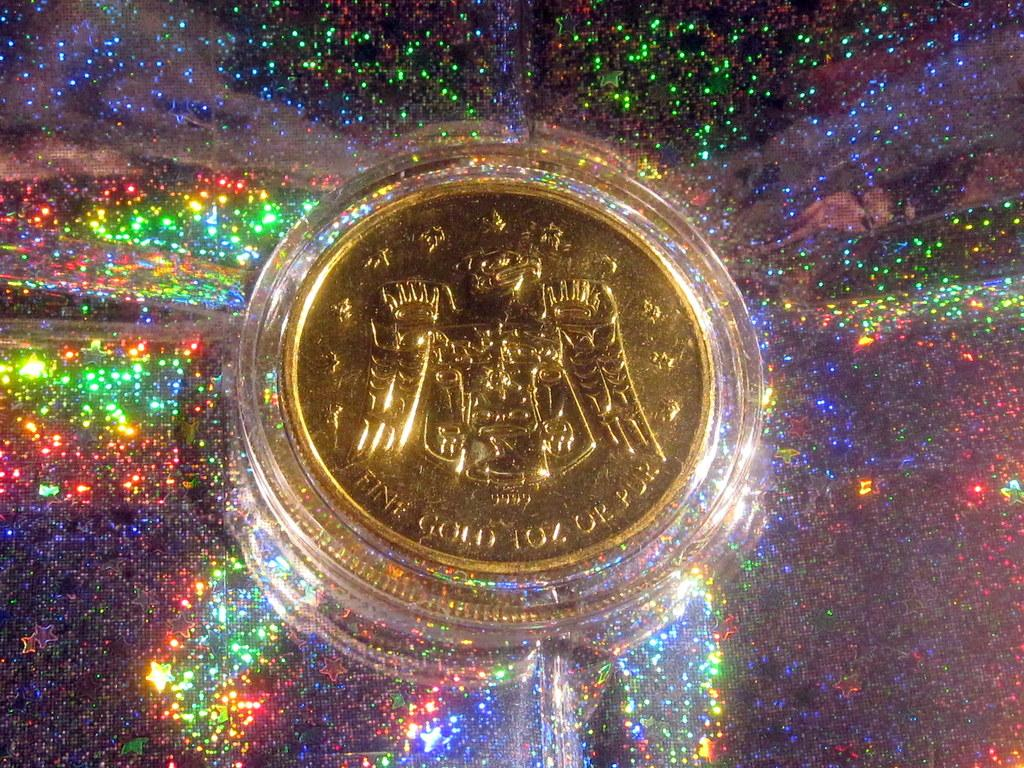What object is the main focus of the image? There is a gold coin in the image. What can be seen in the background of the image? Stars are visible in the background of the image. How would you describe the appearance of the background? The background has a colorful appearance. What type of egg is being used for learning in the image? There is no egg or learning activity present in the image; it features a gold coin and stars in the background. 